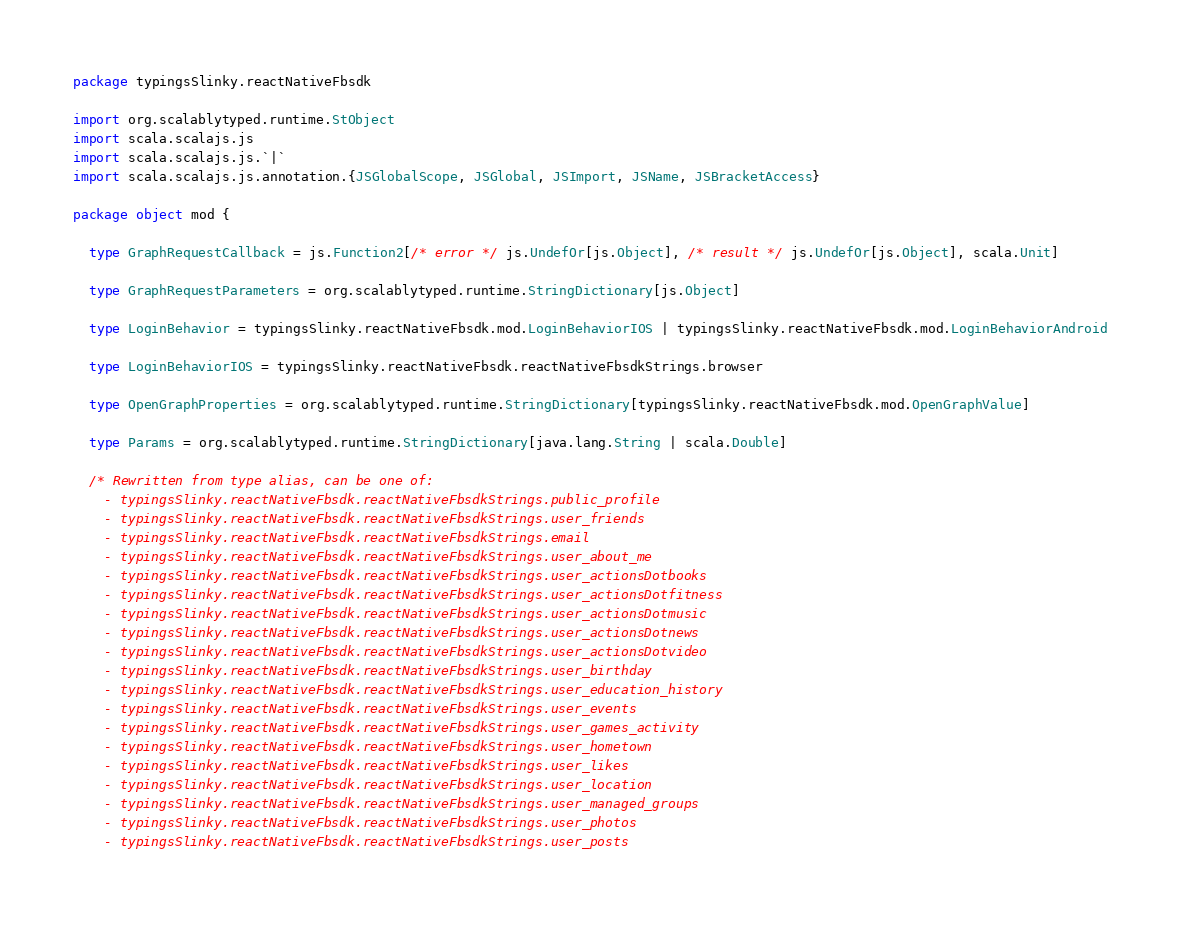<code> <loc_0><loc_0><loc_500><loc_500><_Scala_>package typingsSlinky.reactNativeFbsdk

import org.scalablytyped.runtime.StObject
import scala.scalajs.js
import scala.scalajs.js.`|`
import scala.scalajs.js.annotation.{JSGlobalScope, JSGlobal, JSImport, JSName, JSBracketAccess}

package object mod {
  
  type GraphRequestCallback = js.Function2[/* error */ js.UndefOr[js.Object], /* result */ js.UndefOr[js.Object], scala.Unit]
  
  type GraphRequestParameters = org.scalablytyped.runtime.StringDictionary[js.Object]
  
  type LoginBehavior = typingsSlinky.reactNativeFbsdk.mod.LoginBehaviorIOS | typingsSlinky.reactNativeFbsdk.mod.LoginBehaviorAndroid
  
  type LoginBehaviorIOS = typingsSlinky.reactNativeFbsdk.reactNativeFbsdkStrings.browser
  
  type OpenGraphProperties = org.scalablytyped.runtime.StringDictionary[typingsSlinky.reactNativeFbsdk.mod.OpenGraphValue]
  
  type Params = org.scalablytyped.runtime.StringDictionary[java.lang.String | scala.Double]
  
  /* Rewritten from type alias, can be one of: 
    - typingsSlinky.reactNativeFbsdk.reactNativeFbsdkStrings.public_profile
    - typingsSlinky.reactNativeFbsdk.reactNativeFbsdkStrings.user_friends
    - typingsSlinky.reactNativeFbsdk.reactNativeFbsdkStrings.email
    - typingsSlinky.reactNativeFbsdk.reactNativeFbsdkStrings.user_about_me
    - typingsSlinky.reactNativeFbsdk.reactNativeFbsdkStrings.user_actionsDotbooks
    - typingsSlinky.reactNativeFbsdk.reactNativeFbsdkStrings.user_actionsDotfitness
    - typingsSlinky.reactNativeFbsdk.reactNativeFbsdkStrings.user_actionsDotmusic
    - typingsSlinky.reactNativeFbsdk.reactNativeFbsdkStrings.user_actionsDotnews
    - typingsSlinky.reactNativeFbsdk.reactNativeFbsdkStrings.user_actionsDotvideo
    - typingsSlinky.reactNativeFbsdk.reactNativeFbsdkStrings.user_birthday
    - typingsSlinky.reactNativeFbsdk.reactNativeFbsdkStrings.user_education_history
    - typingsSlinky.reactNativeFbsdk.reactNativeFbsdkStrings.user_events
    - typingsSlinky.reactNativeFbsdk.reactNativeFbsdkStrings.user_games_activity
    - typingsSlinky.reactNativeFbsdk.reactNativeFbsdkStrings.user_hometown
    - typingsSlinky.reactNativeFbsdk.reactNativeFbsdkStrings.user_likes
    - typingsSlinky.reactNativeFbsdk.reactNativeFbsdkStrings.user_location
    - typingsSlinky.reactNativeFbsdk.reactNativeFbsdkStrings.user_managed_groups
    - typingsSlinky.reactNativeFbsdk.reactNativeFbsdkStrings.user_photos
    - typingsSlinky.reactNativeFbsdk.reactNativeFbsdkStrings.user_posts</code> 